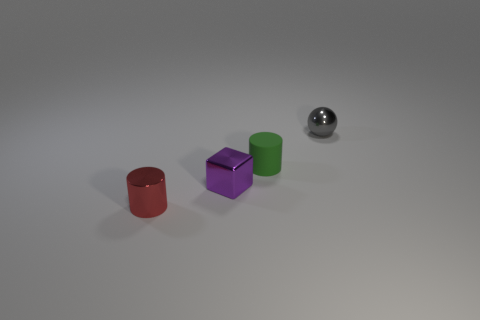Are there any other tiny red objects of the same shape as the matte thing?
Make the answer very short. Yes. How many things are either tiny green matte objects or tiny shiny objects that are in front of the green rubber object?
Provide a short and direct response. 3. What color is the small cylinder that is on the right side of the small purple block?
Keep it short and to the point. Green. Is the size of the metallic object that is behind the purple thing the same as the cylinder that is to the left of the green matte cylinder?
Make the answer very short. Yes. Is there a metallic cylinder that has the same size as the red shiny thing?
Give a very brief answer. No. What number of small green things are behind the cylinder left of the matte cylinder?
Your answer should be compact. 1. What is the tiny red object made of?
Ensure brevity in your answer.  Metal. What number of small cylinders are in front of the small green cylinder?
Offer a very short reply. 1. Is the small matte cylinder the same color as the small metallic cylinder?
Give a very brief answer. No. What number of metallic cylinders have the same color as the tiny sphere?
Your answer should be very brief. 0. 